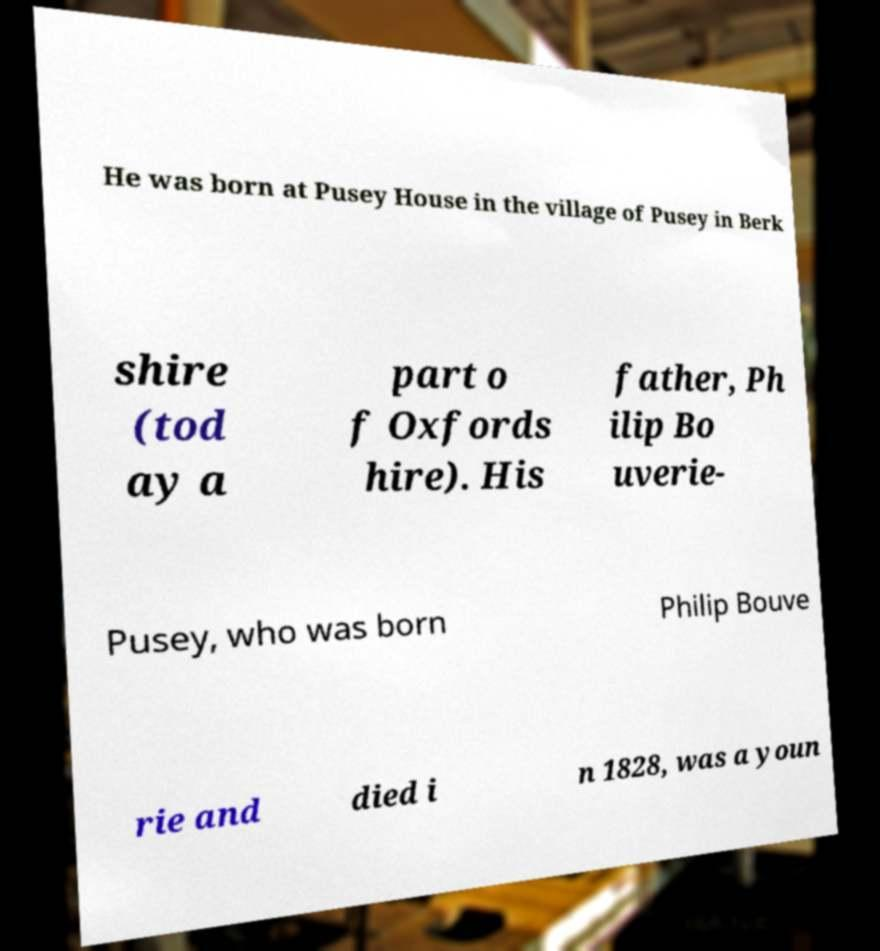Could you assist in decoding the text presented in this image and type it out clearly? He was born at Pusey House in the village of Pusey in Berk shire (tod ay a part o f Oxfords hire). His father, Ph ilip Bo uverie- Pusey, who was born Philip Bouve rie and died i n 1828, was a youn 